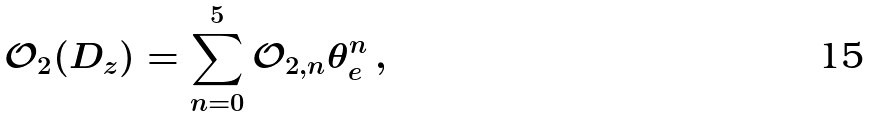<formula> <loc_0><loc_0><loc_500><loc_500>\mathcal { O } _ { 2 } ( D _ { z } ) = \sum _ { n = 0 } ^ { 5 } \mathcal { O } _ { 2 , n } \theta _ { e } ^ { n } \, ,</formula> 